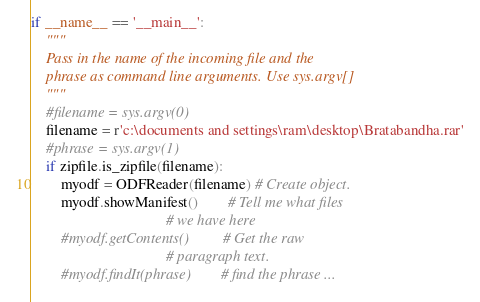<code> <loc_0><loc_0><loc_500><loc_500><_Python_>if __name__ == '__main__':
    """
    Pass in the name of the incoming file and the
    phrase as command line arguments. Use sys.argv[]
    """
    #filename = sys.argv(0)
    filename = r'c:\documents and settings\ram\desktop\Bratabandha.rar'
    #phrase = sys.argv(1)
    if zipfile.is_zipfile(filename):
        myodf = ODFReader(filename) # Create object.
        myodf.showManifest()        # Tell me what files
                                    # we have here
        #myodf.getContents()         # Get the raw
                                    # paragraph text.
        #myodf.findIt(phrase)        # find the phrase ...</code> 